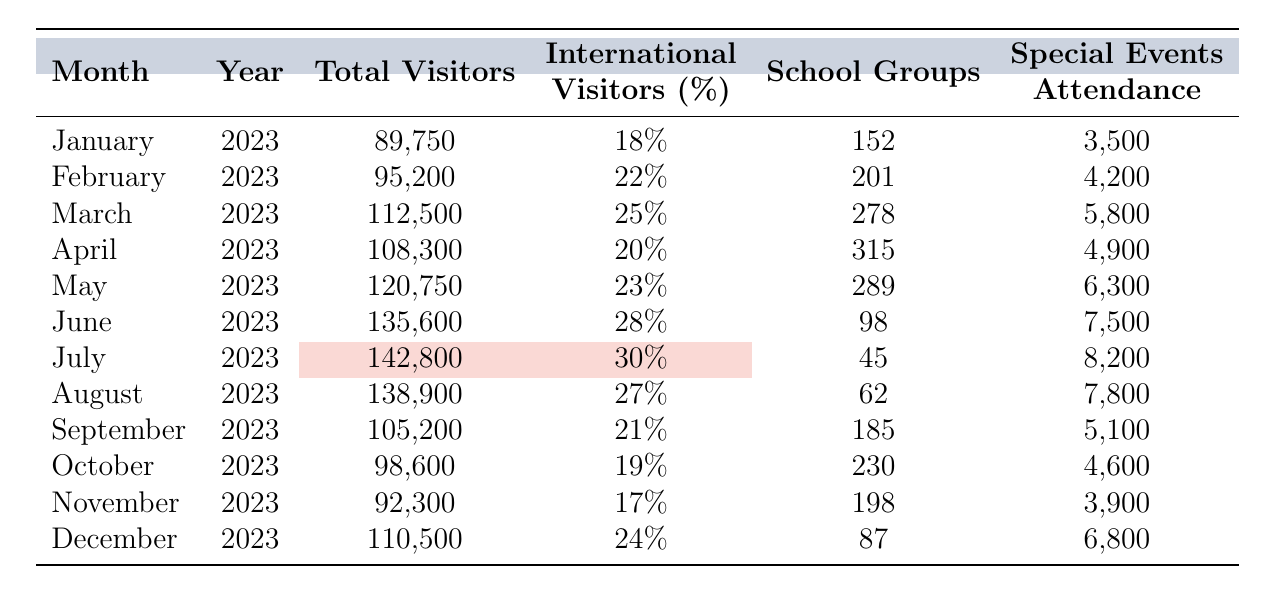What was the month with the highest total visitors? Looking through the total visitors column, I see July 2023 has the highest value with 142,800 visitors.
Answer: July 2023 What percentage of visitors were international in June 2023? In the table, under June 2023, the percentage of international visitors is listed as 28%.
Answer: 28% How many school groups visited in March 2023? The table shows that in March 2023, there were 278 school groups.
Answer: 278 What was the total attendance at special events for the entire year? To find this, I sum the special events attendance for each month: 3,500 + 4,200 + 5,800 + 4,900 + 6,300 + 7,500 + 8,200 + 7,800 + 5,100 + 4,600 + 3,900 + 6,800. This sums up to 57,800.
Answer: 57,800 Was the percentage of international visitors higher in May 2023 or June 2023? In May 2023 the percentage was 23%, and in June 2023 it was 28%. Since 28% is greater than 23%, June had a higher percentage.
Answer: Yes What was the average number of total visitors per month for the year? By summing the total visitors: 89750 + 95200 + 112500 + 108300 + 120750 + 135600 + 142800 + 138900 + 105200 + 98600 + 92300 + 110500 = 1,508,300. There are 12 months, so dividing gives 1,508,300 / 12 = 125,691.67.
Answer: 125,691.67 How much did total visitors decrease from July 2023 to October 2023? Total visitors in July 2023 were 142,800, and in October 2023 were 98,600. The decrease is 142,800 - 98,600 = 44,200.
Answer: 44,200 Which month had the lowest attendance from school groups, and what was it? The lowest attendance from school groups was in July 2023, with only 45 school groups visiting.
Answer: July 2023, 45 school groups Is the total visitors in November 2023 higher than in January 2023? The total visitors in November 2023 were 92,300 and in January 2023 were 89,750. Since 92,300 is greater than 89,750, the answer is yes.
Answer: Yes What is the median number of total visitors for the whole year? Listing total visitors in order: 89,750, 92,300, 95,200, 98,600, 105,200, 108,300, 110,500, 112,500, 120,750, 135,600, 138,900, 142,800 gives 12 data points. The median is the average of the 6th and 7th values: (108,300 + 110,500) / 2 = 109,400.
Answer: 109,400 What was the total percentage of international visitors throughout the year? To find this, I'd need to multiply the total visitors by their respective international percentages, sum those values, and then divide by the total number of visitors. It provides insight for each month, but it would require more calculations.
Answer: Not calculated (requires more information) 